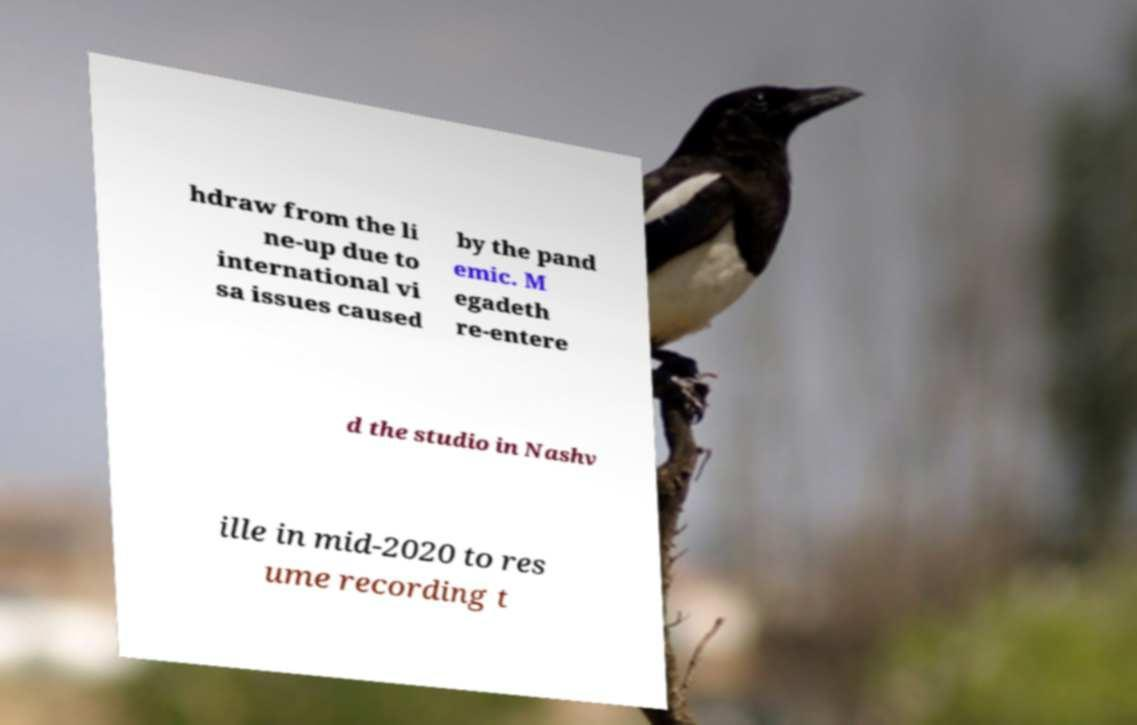Please identify and transcribe the text found in this image. hdraw from the li ne-up due to international vi sa issues caused by the pand emic. M egadeth re-entere d the studio in Nashv ille in mid-2020 to res ume recording t 